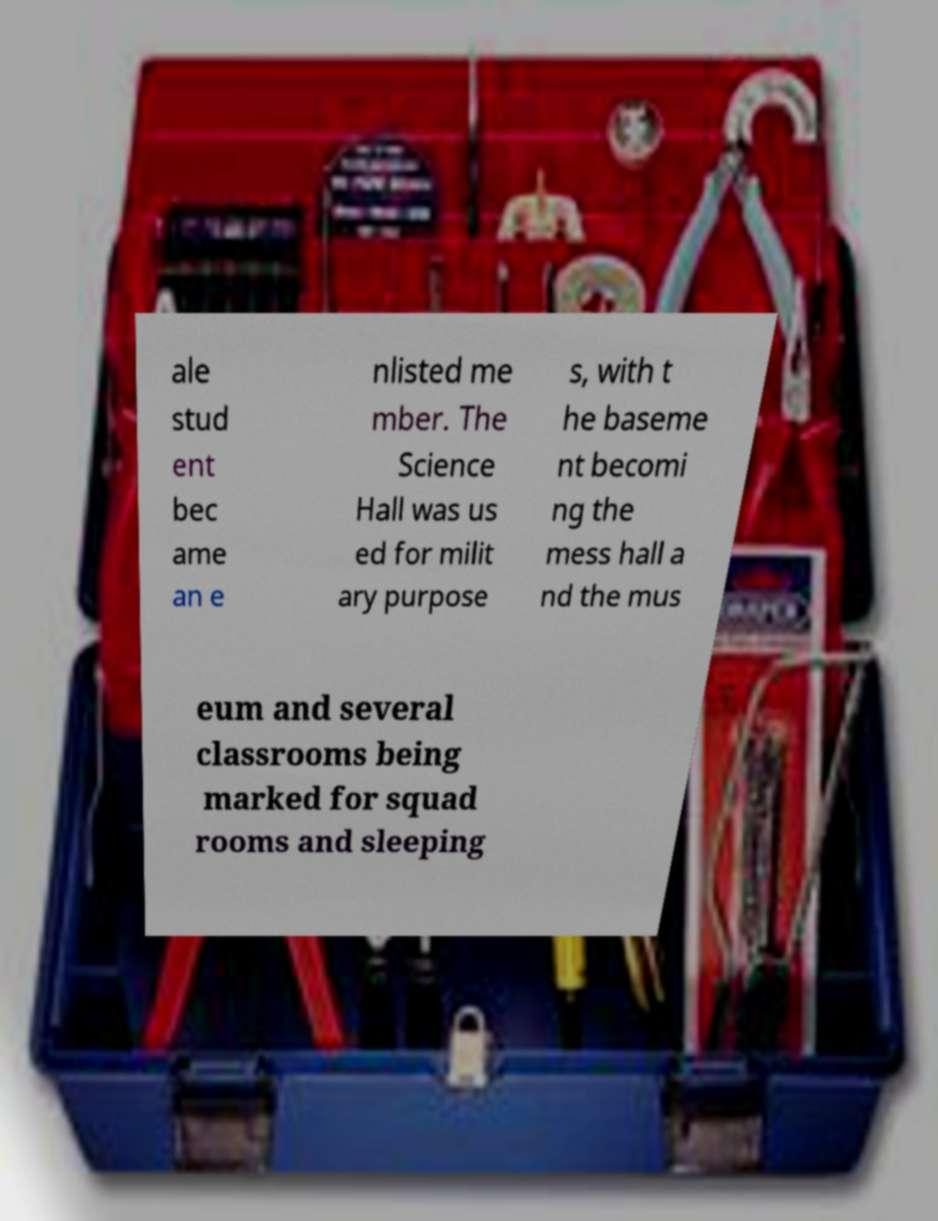What messages or text are displayed in this image? I need them in a readable, typed format. ale stud ent bec ame an e nlisted me mber. The Science Hall was us ed for milit ary purpose s, with t he baseme nt becomi ng the mess hall a nd the mus eum and several classrooms being marked for squad rooms and sleeping 